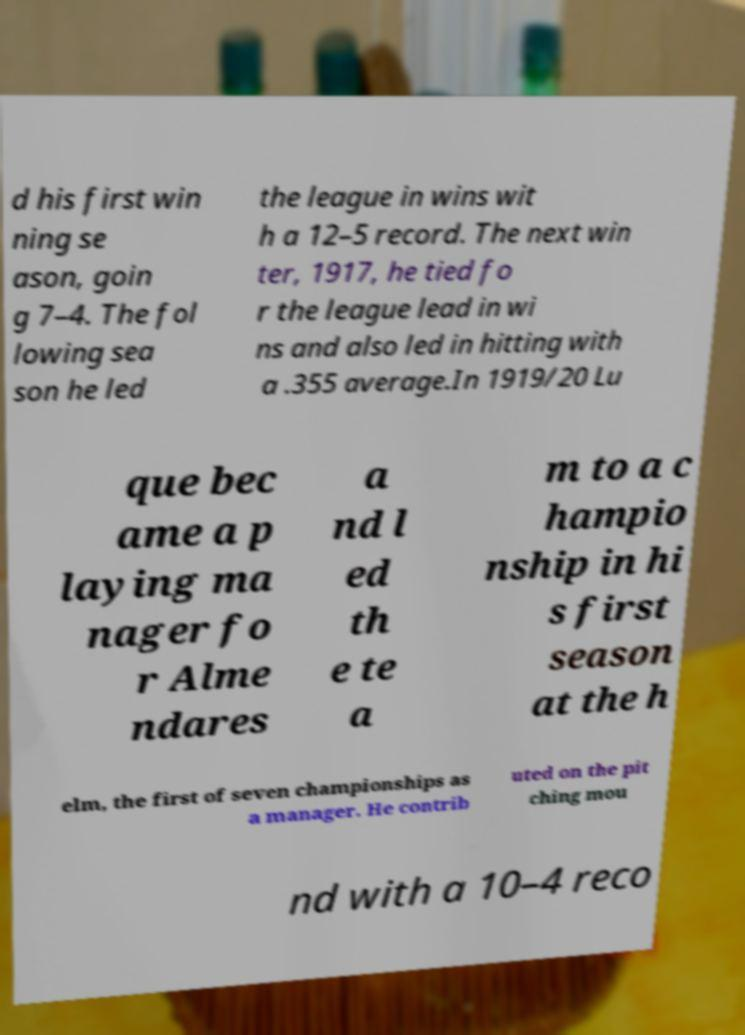Could you extract and type out the text from this image? d his first win ning se ason, goin g 7–4. The fol lowing sea son he led the league in wins wit h a 12–5 record. The next win ter, 1917, he tied fo r the league lead in wi ns and also led in hitting with a .355 average.In 1919/20 Lu que bec ame a p laying ma nager fo r Alme ndares a nd l ed th e te a m to a c hampio nship in hi s first season at the h elm, the first of seven championships as a manager. He contrib uted on the pit ching mou nd with a 10–4 reco 